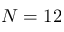Convert formula to latex. <formula><loc_0><loc_0><loc_500><loc_500>N = 1 2</formula> 